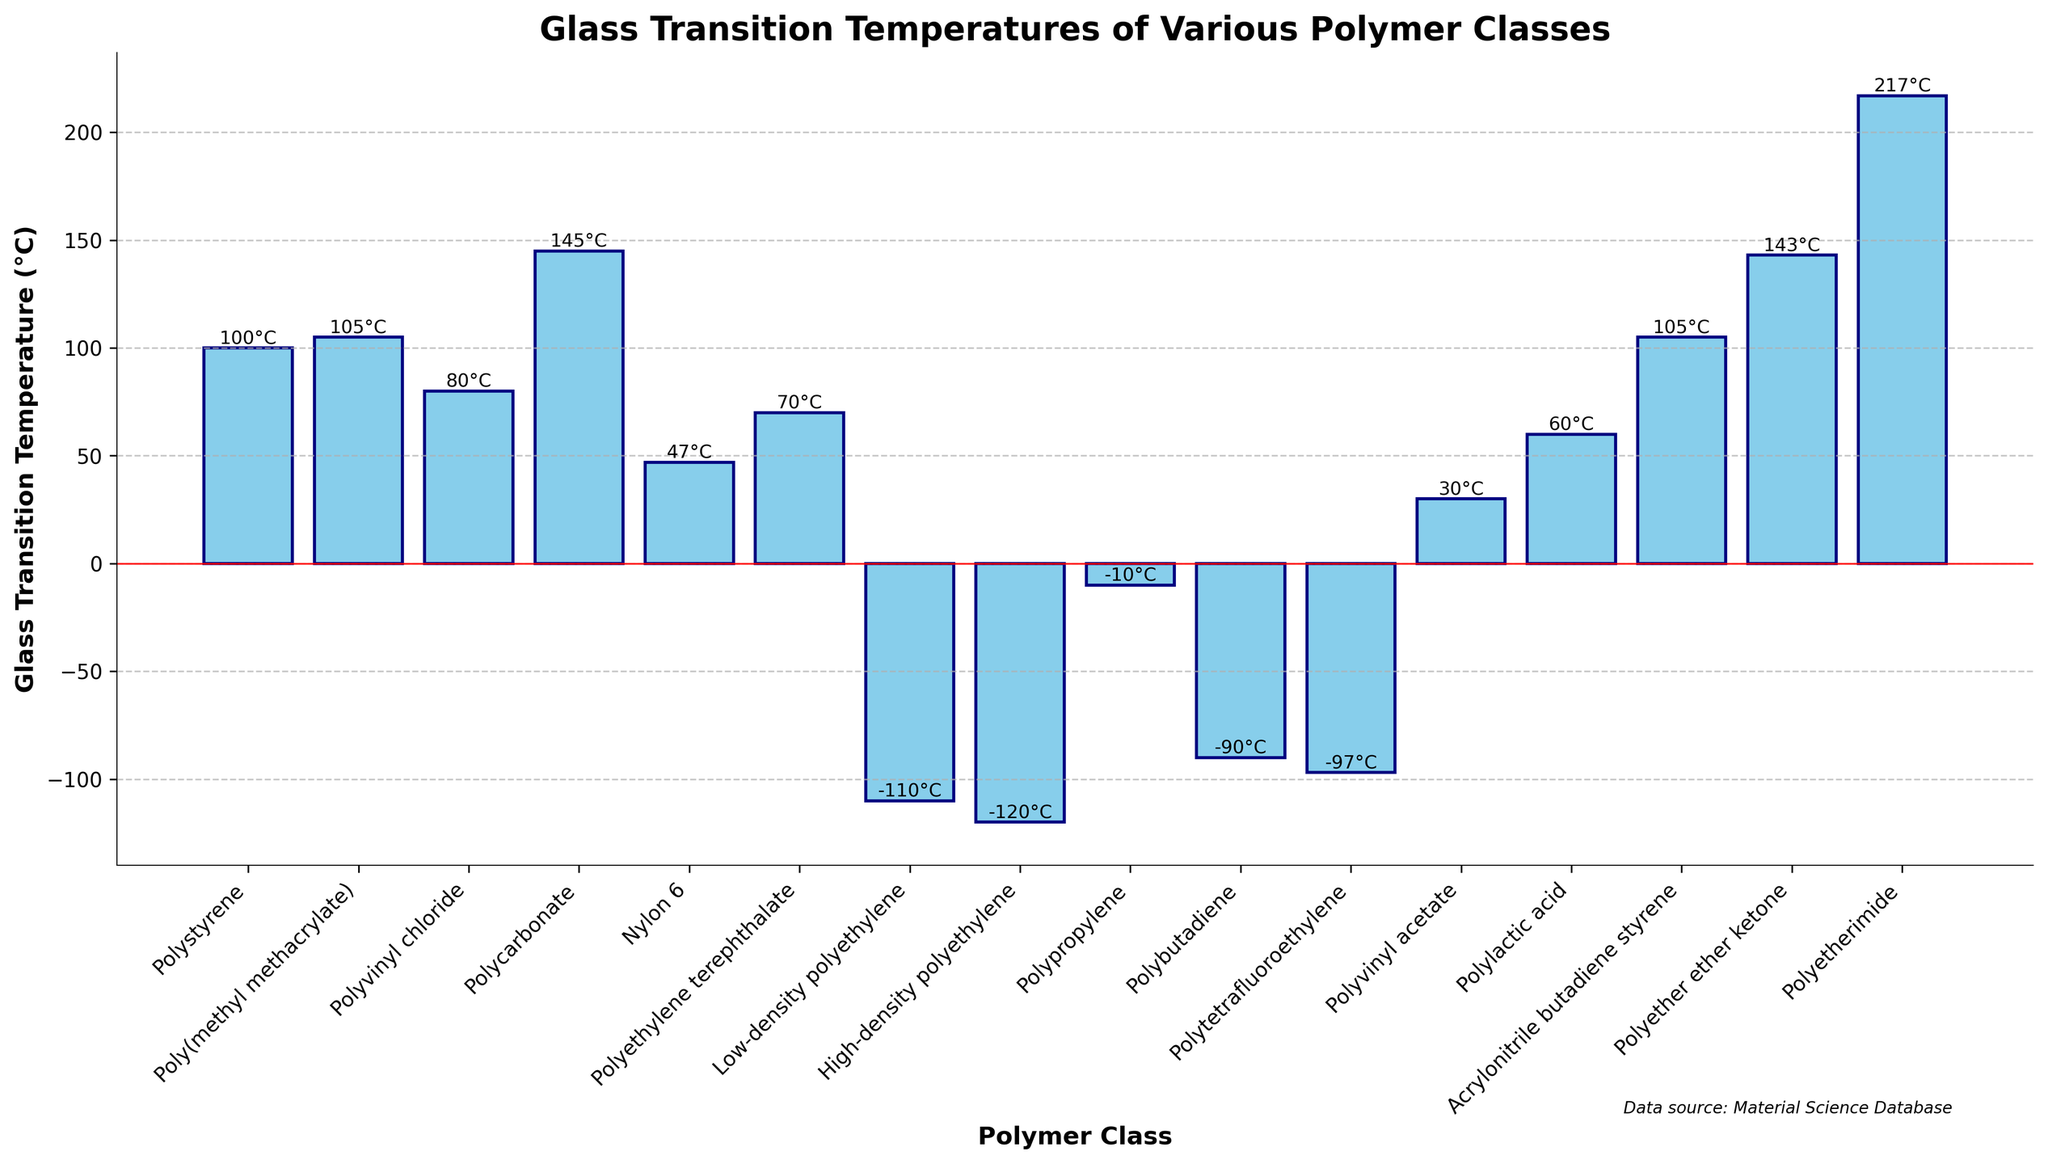Which polymer class has the highest glass transition temperature? The bar chart shows the glass transition temperatures for various polymer classes, and the one with the highest temperature has the tallest bar. Polyetherimide has the highest glass transition temperature at 217°C.
Answer: Polyetherimide Which polymer classes have glass transition temperatures less than 0°C? The bars that extend below the red horizontal line at 0°C represent polymer classes with glass transition temperatures below 0°C. These polymer classes are Low-density polyethylene, High-density polyethylene, Polybutadiene, Polytetrafluoroethylene, and Polypropylene.
Answer: Low-density polyethylene, High-density polyethylene, Polybutadiene, Polytetrafluoroethylene, Polypropylene What is the difference in glass transition temperature between Polycarbonate and Nylon 6? To find the difference, subtract the glass transition temperature of Nylon 6 from that of Polycarbonate. Polycarbonate is 145°C and Nylon 6 is 47°C, so 145 - 47 = 98°C.
Answer: 98°C Calculate the average glass transition temperature of Polystyrene, Poly(methyl methacrylate), and Acrylonitrile butadiene styrene. Add the glass transition temperatures of the three polymers and divide by 3. (100 + 105 + 105)/3 = 310/3 ≈ 103.33°C.
Answer: 103.33°C Which polymer has a glass transition temperature closest to room temperature (25°C)? Compare the glass transition temperatures of the polymers to 25°C and find the one with the smallest difference. Polyvinyl acetate has a glass transition temperature of 30°C, which is closest to 25°C.
Answer: Polyvinyl acetate Arrange Polyvinyl chloride, Polyethylene terephthalate, and Polybutadiene in increasing order of their glass transition temperatures. List the glass transition temperatures first: Polyvinyl chloride (80°C), Polyethylene terephthalate (70°C), and Polybutadiene (-90°C). Then arrange them from lowest to highest: Polybutadiene (-90°C), Polyethylene terephthalate (70°C), and Polyvinyl chloride (80°C).
Answer: Polybutadiene, Polyethylene terephthalate, Polyvinyl chloride Which two polymer classes have the same glass transition temperature? Look for bars that reach the same height. Poly(methyl methacrylate) and Acrylonitrile butadiene styrene both have a glass transition temperature of 105°C.
Answer: Poly(methyl methacrylate) and Acrylonitrile butadiene styrene How many polymers have glass transition temperatures above 100°C? Count the number of bars that extend above the 100°C mark on the y-axis. There are six such polymers: Polystyrene, Poly(methyl methacrylate), Polycarbonate, Acrylonitrile butadiene styrene, Polyether ether ketone, and Polyetherimide.
Answer: 6 